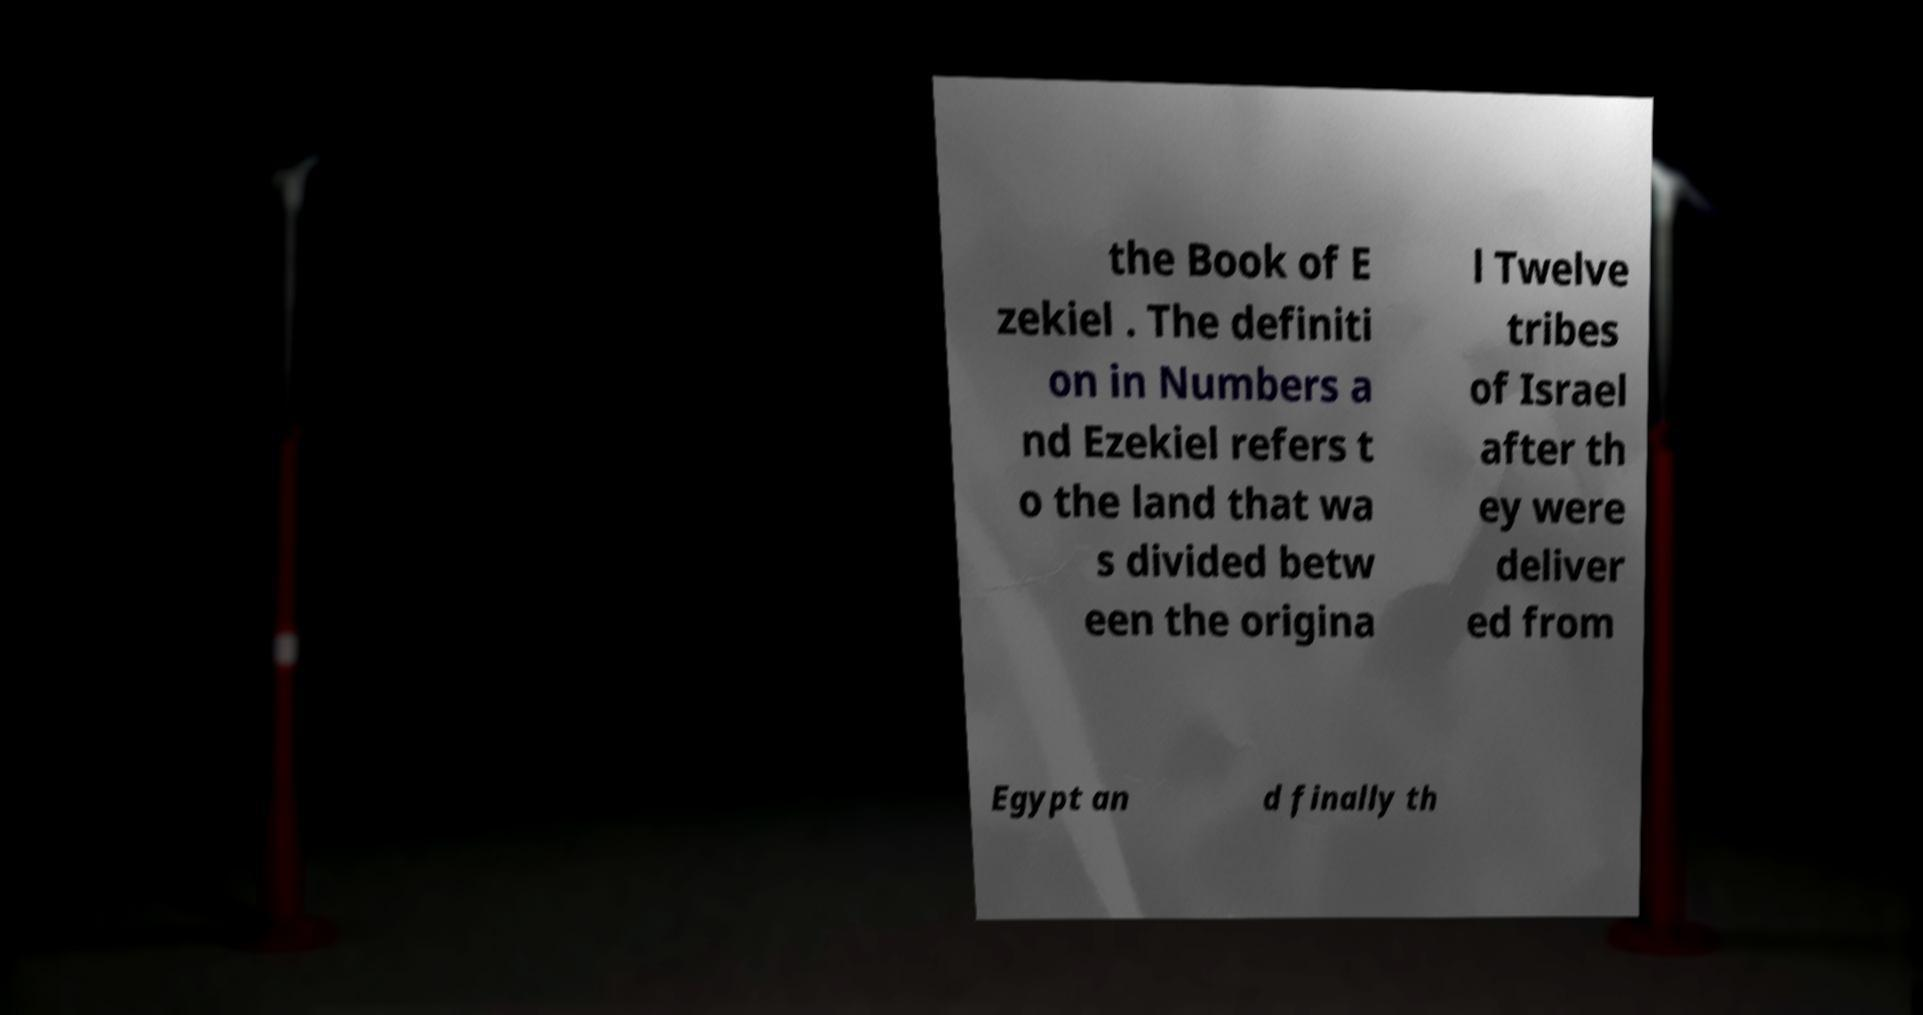Please identify and transcribe the text found in this image. the Book of E zekiel . The definiti on in Numbers a nd Ezekiel refers t o the land that wa s divided betw een the origina l Twelve tribes of Israel after th ey were deliver ed from Egypt an d finally th 